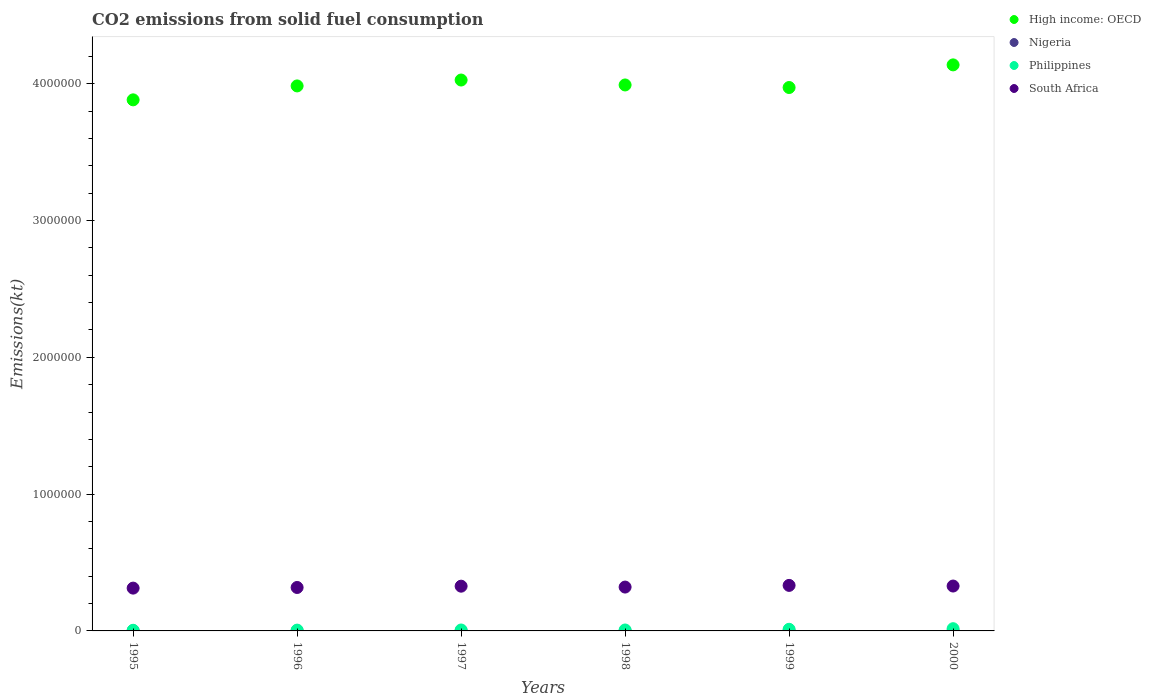How many different coloured dotlines are there?
Provide a short and direct response. 4. What is the amount of CO2 emitted in Philippines in 1995?
Make the answer very short. 4697.43. Across all years, what is the maximum amount of CO2 emitted in Philippines?
Your answer should be compact. 1.63e+04. Across all years, what is the minimum amount of CO2 emitted in Philippines?
Provide a short and direct response. 4697.43. What is the total amount of CO2 emitted in South Africa in the graph?
Your answer should be compact. 1.94e+06. What is the difference between the amount of CO2 emitted in Philippines in 1996 and that in 2000?
Offer a terse response. -1.04e+04. What is the difference between the amount of CO2 emitted in South Africa in 1998 and the amount of CO2 emitted in High income: OECD in 1996?
Provide a succinct answer. -3.66e+06. What is the average amount of CO2 emitted in Philippines per year?
Ensure brevity in your answer.  8743.96. In the year 1996, what is the difference between the amount of CO2 emitted in South Africa and amount of CO2 emitted in Nigeria?
Provide a short and direct response. 3.17e+05. In how many years, is the amount of CO2 emitted in Nigeria greater than 400000 kt?
Ensure brevity in your answer.  0. What is the ratio of the amount of CO2 emitted in High income: OECD in 1996 to that in 1999?
Provide a succinct answer. 1. Is the difference between the amount of CO2 emitted in South Africa in 1995 and 1999 greater than the difference between the amount of CO2 emitted in Nigeria in 1995 and 1999?
Give a very brief answer. No. What is the difference between the highest and the second highest amount of CO2 emitted in Philippines?
Make the answer very short. 4429.74. What is the difference between the highest and the lowest amount of CO2 emitted in Nigeria?
Give a very brief answer. 370.37. Is the sum of the amount of CO2 emitted in Nigeria in 1995 and 1997 greater than the maximum amount of CO2 emitted in Philippines across all years?
Your answer should be compact. No. Is it the case that in every year, the sum of the amount of CO2 emitted in High income: OECD and amount of CO2 emitted in South Africa  is greater than the amount of CO2 emitted in Nigeria?
Offer a very short reply. Yes. Is the amount of CO2 emitted in Nigeria strictly greater than the amount of CO2 emitted in High income: OECD over the years?
Keep it short and to the point. No. Is the amount of CO2 emitted in Nigeria strictly less than the amount of CO2 emitted in Philippines over the years?
Offer a terse response. Yes. How many dotlines are there?
Your response must be concise. 4. Does the graph contain any zero values?
Ensure brevity in your answer.  No. Does the graph contain grids?
Provide a succinct answer. No. How are the legend labels stacked?
Offer a very short reply. Vertical. What is the title of the graph?
Provide a short and direct response. CO2 emissions from solid fuel consumption. What is the label or title of the X-axis?
Ensure brevity in your answer.  Years. What is the label or title of the Y-axis?
Offer a very short reply. Emissions(kt). What is the Emissions(kt) of High income: OECD in 1995?
Give a very brief answer. 3.88e+06. What is the Emissions(kt) of Nigeria in 1995?
Offer a very short reply. 388.7. What is the Emissions(kt) of Philippines in 1995?
Your answer should be very brief. 4697.43. What is the Emissions(kt) of South Africa in 1995?
Keep it short and to the point. 3.13e+05. What is the Emissions(kt) in High income: OECD in 1996?
Your response must be concise. 3.98e+06. What is the Emissions(kt) in Nigeria in 1996?
Provide a succinct answer. 388.7. What is the Emissions(kt) of Philippines in 1996?
Give a very brief answer. 5907.54. What is the Emissions(kt) of South Africa in 1996?
Provide a succinct answer. 3.18e+05. What is the Emissions(kt) of High income: OECD in 1997?
Make the answer very short. 4.03e+06. What is the Emissions(kt) of Nigeria in 1997?
Offer a terse response. 44. What is the Emissions(kt) of Philippines in 1997?
Provide a short and direct response. 6794.95. What is the Emissions(kt) in South Africa in 1997?
Ensure brevity in your answer.  3.27e+05. What is the Emissions(kt) in High income: OECD in 1998?
Your response must be concise. 3.99e+06. What is the Emissions(kt) in Nigeria in 1998?
Your answer should be very brief. 47.67. What is the Emissions(kt) in Philippines in 1998?
Your response must be concise. 6864.62. What is the Emissions(kt) in South Africa in 1998?
Offer a terse response. 3.21e+05. What is the Emissions(kt) in High income: OECD in 1999?
Ensure brevity in your answer.  3.97e+06. What is the Emissions(kt) in Nigeria in 1999?
Offer a very short reply. 55.01. What is the Emissions(kt) of Philippines in 1999?
Your answer should be compact. 1.19e+04. What is the Emissions(kt) in South Africa in 1999?
Offer a very short reply. 3.33e+05. What is the Emissions(kt) of High income: OECD in 2000?
Your answer should be very brief. 4.14e+06. What is the Emissions(kt) of Nigeria in 2000?
Your response must be concise. 18.34. What is the Emissions(kt) in Philippines in 2000?
Ensure brevity in your answer.  1.63e+04. What is the Emissions(kt) of South Africa in 2000?
Provide a succinct answer. 3.28e+05. Across all years, what is the maximum Emissions(kt) of High income: OECD?
Your response must be concise. 4.14e+06. Across all years, what is the maximum Emissions(kt) in Nigeria?
Give a very brief answer. 388.7. Across all years, what is the maximum Emissions(kt) in Philippines?
Offer a very short reply. 1.63e+04. Across all years, what is the maximum Emissions(kt) of South Africa?
Your response must be concise. 3.33e+05. Across all years, what is the minimum Emissions(kt) in High income: OECD?
Keep it short and to the point. 3.88e+06. Across all years, what is the minimum Emissions(kt) in Nigeria?
Keep it short and to the point. 18.34. Across all years, what is the minimum Emissions(kt) of Philippines?
Provide a succinct answer. 4697.43. Across all years, what is the minimum Emissions(kt) of South Africa?
Your answer should be very brief. 3.13e+05. What is the total Emissions(kt) of High income: OECD in the graph?
Your response must be concise. 2.40e+07. What is the total Emissions(kt) in Nigeria in the graph?
Offer a terse response. 942.42. What is the total Emissions(kt) in Philippines in the graph?
Make the answer very short. 5.25e+04. What is the total Emissions(kt) in South Africa in the graph?
Make the answer very short. 1.94e+06. What is the difference between the Emissions(kt) of High income: OECD in 1995 and that in 1996?
Offer a terse response. -1.02e+05. What is the difference between the Emissions(kt) of Philippines in 1995 and that in 1996?
Ensure brevity in your answer.  -1210.11. What is the difference between the Emissions(kt) of South Africa in 1995 and that in 1996?
Provide a short and direct response. -4697.43. What is the difference between the Emissions(kt) in High income: OECD in 1995 and that in 1997?
Your response must be concise. -1.45e+05. What is the difference between the Emissions(kt) of Nigeria in 1995 and that in 1997?
Make the answer very short. 344.7. What is the difference between the Emissions(kt) of Philippines in 1995 and that in 1997?
Your answer should be compact. -2097.52. What is the difference between the Emissions(kt) in South Africa in 1995 and that in 1997?
Give a very brief answer. -1.42e+04. What is the difference between the Emissions(kt) in High income: OECD in 1995 and that in 1998?
Your answer should be very brief. -1.09e+05. What is the difference between the Emissions(kt) in Nigeria in 1995 and that in 1998?
Offer a terse response. 341.03. What is the difference between the Emissions(kt) in Philippines in 1995 and that in 1998?
Provide a succinct answer. -2167.2. What is the difference between the Emissions(kt) in South Africa in 1995 and that in 1998?
Ensure brevity in your answer.  -7693.37. What is the difference between the Emissions(kt) of High income: OECD in 1995 and that in 1999?
Keep it short and to the point. -9.01e+04. What is the difference between the Emissions(kt) in Nigeria in 1995 and that in 1999?
Your answer should be compact. 333.7. What is the difference between the Emissions(kt) of Philippines in 1995 and that in 1999?
Make the answer very short. -7187.32. What is the difference between the Emissions(kt) in South Africa in 1995 and that in 1999?
Make the answer very short. -1.99e+04. What is the difference between the Emissions(kt) in High income: OECD in 1995 and that in 2000?
Provide a short and direct response. -2.56e+05. What is the difference between the Emissions(kt) in Nigeria in 1995 and that in 2000?
Provide a succinct answer. 370.37. What is the difference between the Emissions(kt) in Philippines in 1995 and that in 2000?
Ensure brevity in your answer.  -1.16e+04. What is the difference between the Emissions(kt) of South Africa in 1995 and that in 2000?
Provide a succinct answer. -1.52e+04. What is the difference between the Emissions(kt) of High income: OECD in 1996 and that in 1997?
Provide a short and direct response. -4.31e+04. What is the difference between the Emissions(kt) of Nigeria in 1996 and that in 1997?
Your answer should be very brief. 344.7. What is the difference between the Emissions(kt) in Philippines in 1996 and that in 1997?
Keep it short and to the point. -887.41. What is the difference between the Emissions(kt) of South Africa in 1996 and that in 1997?
Keep it short and to the point. -9460.86. What is the difference between the Emissions(kt) of High income: OECD in 1996 and that in 1998?
Offer a terse response. -7058.98. What is the difference between the Emissions(kt) of Nigeria in 1996 and that in 1998?
Offer a very short reply. 341.03. What is the difference between the Emissions(kt) of Philippines in 1996 and that in 1998?
Your response must be concise. -957.09. What is the difference between the Emissions(kt) in South Africa in 1996 and that in 1998?
Your response must be concise. -2995.94. What is the difference between the Emissions(kt) of High income: OECD in 1996 and that in 1999?
Keep it short and to the point. 1.16e+04. What is the difference between the Emissions(kt) in Nigeria in 1996 and that in 1999?
Give a very brief answer. 333.7. What is the difference between the Emissions(kt) of Philippines in 1996 and that in 1999?
Ensure brevity in your answer.  -5977.21. What is the difference between the Emissions(kt) in South Africa in 1996 and that in 1999?
Provide a short and direct response. -1.52e+04. What is the difference between the Emissions(kt) of High income: OECD in 1996 and that in 2000?
Your answer should be compact. -1.54e+05. What is the difference between the Emissions(kt) of Nigeria in 1996 and that in 2000?
Offer a terse response. 370.37. What is the difference between the Emissions(kt) in Philippines in 1996 and that in 2000?
Keep it short and to the point. -1.04e+04. What is the difference between the Emissions(kt) of South Africa in 1996 and that in 2000?
Make the answer very short. -1.05e+04. What is the difference between the Emissions(kt) in High income: OECD in 1997 and that in 1998?
Offer a very short reply. 3.60e+04. What is the difference between the Emissions(kt) in Nigeria in 1997 and that in 1998?
Give a very brief answer. -3.67. What is the difference between the Emissions(kt) of Philippines in 1997 and that in 1998?
Give a very brief answer. -69.67. What is the difference between the Emissions(kt) in South Africa in 1997 and that in 1998?
Provide a short and direct response. 6464.92. What is the difference between the Emissions(kt) in High income: OECD in 1997 and that in 1999?
Your answer should be very brief. 5.47e+04. What is the difference between the Emissions(kt) in Nigeria in 1997 and that in 1999?
Offer a very short reply. -11. What is the difference between the Emissions(kt) in Philippines in 1997 and that in 1999?
Give a very brief answer. -5089.8. What is the difference between the Emissions(kt) of South Africa in 1997 and that in 1999?
Keep it short and to the point. -5771.86. What is the difference between the Emissions(kt) of High income: OECD in 1997 and that in 2000?
Ensure brevity in your answer.  -1.11e+05. What is the difference between the Emissions(kt) of Nigeria in 1997 and that in 2000?
Your answer should be compact. 25.67. What is the difference between the Emissions(kt) of Philippines in 1997 and that in 2000?
Provide a succinct answer. -9519.53. What is the difference between the Emissions(kt) in South Africa in 1997 and that in 2000?
Your response must be concise. -1059.76. What is the difference between the Emissions(kt) in High income: OECD in 1998 and that in 1999?
Offer a terse response. 1.87e+04. What is the difference between the Emissions(kt) of Nigeria in 1998 and that in 1999?
Keep it short and to the point. -7.33. What is the difference between the Emissions(kt) in Philippines in 1998 and that in 1999?
Keep it short and to the point. -5020.12. What is the difference between the Emissions(kt) of South Africa in 1998 and that in 1999?
Give a very brief answer. -1.22e+04. What is the difference between the Emissions(kt) in High income: OECD in 1998 and that in 2000?
Provide a short and direct response. -1.47e+05. What is the difference between the Emissions(kt) of Nigeria in 1998 and that in 2000?
Offer a terse response. 29.34. What is the difference between the Emissions(kt) of Philippines in 1998 and that in 2000?
Offer a terse response. -9449.86. What is the difference between the Emissions(kt) of South Africa in 1998 and that in 2000?
Provide a short and direct response. -7524.68. What is the difference between the Emissions(kt) in High income: OECD in 1999 and that in 2000?
Offer a terse response. -1.65e+05. What is the difference between the Emissions(kt) of Nigeria in 1999 and that in 2000?
Provide a short and direct response. 36.67. What is the difference between the Emissions(kt) of Philippines in 1999 and that in 2000?
Keep it short and to the point. -4429.74. What is the difference between the Emissions(kt) of South Africa in 1999 and that in 2000?
Your answer should be very brief. 4712.1. What is the difference between the Emissions(kt) in High income: OECD in 1995 and the Emissions(kt) in Nigeria in 1996?
Provide a succinct answer. 3.88e+06. What is the difference between the Emissions(kt) in High income: OECD in 1995 and the Emissions(kt) in Philippines in 1996?
Make the answer very short. 3.88e+06. What is the difference between the Emissions(kt) of High income: OECD in 1995 and the Emissions(kt) of South Africa in 1996?
Offer a very short reply. 3.56e+06. What is the difference between the Emissions(kt) in Nigeria in 1995 and the Emissions(kt) in Philippines in 1996?
Keep it short and to the point. -5518.84. What is the difference between the Emissions(kt) of Nigeria in 1995 and the Emissions(kt) of South Africa in 1996?
Ensure brevity in your answer.  -3.17e+05. What is the difference between the Emissions(kt) of Philippines in 1995 and the Emissions(kt) of South Africa in 1996?
Provide a succinct answer. -3.13e+05. What is the difference between the Emissions(kt) of High income: OECD in 1995 and the Emissions(kt) of Nigeria in 1997?
Provide a succinct answer. 3.88e+06. What is the difference between the Emissions(kt) in High income: OECD in 1995 and the Emissions(kt) in Philippines in 1997?
Your answer should be very brief. 3.88e+06. What is the difference between the Emissions(kt) of High income: OECD in 1995 and the Emissions(kt) of South Africa in 1997?
Your response must be concise. 3.56e+06. What is the difference between the Emissions(kt) in Nigeria in 1995 and the Emissions(kt) in Philippines in 1997?
Provide a succinct answer. -6406.25. What is the difference between the Emissions(kt) of Nigeria in 1995 and the Emissions(kt) of South Africa in 1997?
Provide a short and direct response. -3.27e+05. What is the difference between the Emissions(kt) in Philippines in 1995 and the Emissions(kt) in South Africa in 1997?
Your response must be concise. -3.22e+05. What is the difference between the Emissions(kt) of High income: OECD in 1995 and the Emissions(kt) of Nigeria in 1998?
Offer a terse response. 3.88e+06. What is the difference between the Emissions(kt) of High income: OECD in 1995 and the Emissions(kt) of Philippines in 1998?
Make the answer very short. 3.88e+06. What is the difference between the Emissions(kt) of High income: OECD in 1995 and the Emissions(kt) of South Africa in 1998?
Keep it short and to the point. 3.56e+06. What is the difference between the Emissions(kt) in Nigeria in 1995 and the Emissions(kt) in Philippines in 1998?
Provide a short and direct response. -6475.92. What is the difference between the Emissions(kt) of Nigeria in 1995 and the Emissions(kt) of South Africa in 1998?
Your answer should be very brief. -3.20e+05. What is the difference between the Emissions(kt) of Philippines in 1995 and the Emissions(kt) of South Africa in 1998?
Provide a succinct answer. -3.16e+05. What is the difference between the Emissions(kt) in High income: OECD in 1995 and the Emissions(kt) in Nigeria in 1999?
Make the answer very short. 3.88e+06. What is the difference between the Emissions(kt) of High income: OECD in 1995 and the Emissions(kt) of Philippines in 1999?
Your answer should be compact. 3.87e+06. What is the difference between the Emissions(kt) of High income: OECD in 1995 and the Emissions(kt) of South Africa in 1999?
Your answer should be very brief. 3.55e+06. What is the difference between the Emissions(kt) in Nigeria in 1995 and the Emissions(kt) in Philippines in 1999?
Offer a very short reply. -1.15e+04. What is the difference between the Emissions(kt) in Nigeria in 1995 and the Emissions(kt) in South Africa in 1999?
Your response must be concise. -3.32e+05. What is the difference between the Emissions(kt) in Philippines in 1995 and the Emissions(kt) in South Africa in 1999?
Your response must be concise. -3.28e+05. What is the difference between the Emissions(kt) of High income: OECD in 1995 and the Emissions(kt) of Nigeria in 2000?
Your answer should be compact. 3.88e+06. What is the difference between the Emissions(kt) in High income: OECD in 1995 and the Emissions(kt) in Philippines in 2000?
Make the answer very short. 3.87e+06. What is the difference between the Emissions(kt) of High income: OECD in 1995 and the Emissions(kt) of South Africa in 2000?
Keep it short and to the point. 3.55e+06. What is the difference between the Emissions(kt) in Nigeria in 1995 and the Emissions(kt) in Philippines in 2000?
Offer a terse response. -1.59e+04. What is the difference between the Emissions(kt) of Nigeria in 1995 and the Emissions(kt) of South Africa in 2000?
Keep it short and to the point. -3.28e+05. What is the difference between the Emissions(kt) of Philippines in 1995 and the Emissions(kt) of South Africa in 2000?
Provide a short and direct response. -3.23e+05. What is the difference between the Emissions(kt) of High income: OECD in 1996 and the Emissions(kt) of Nigeria in 1997?
Your response must be concise. 3.98e+06. What is the difference between the Emissions(kt) of High income: OECD in 1996 and the Emissions(kt) of Philippines in 1997?
Your answer should be very brief. 3.98e+06. What is the difference between the Emissions(kt) in High income: OECD in 1996 and the Emissions(kt) in South Africa in 1997?
Make the answer very short. 3.66e+06. What is the difference between the Emissions(kt) in Nigeria in 1996 and the Emissions(kt) in Philippines in 1997?
Keep it short and to the point. -6406.25. What is the difference between the Emissions(kt) in Nigeria in 1996 and the Emissions(kt) in South Africa in 1997?
Give a very brief answer. -3.27e+05. What is the difference between the Emissions(kt) of Philippines in 1996 and the Emissions(kt) of South Africa in 1997?
Offer a terse response. -3.21e+05. What is the difference between the Emissions(kt) of High income: OECD in 1996 and the Emissions(kt) of Nigeria in 1998?
Provide a short and direct response. 3.98e+06. What is the difference between the Emissions(kt) of High income: OECD in 1996 and the Emissions(kt) of Philippines in 1998?
Give a very brief answer. 3.98e+06. What is the difference between the Emissions(kt) of High income: OECD in 1996 and the Emissions(kt) of South Africa in 1998?
Provide a succinct answer. 3.66e+06. What is the difference between the Emissions(kt) of Nigeria in 1996 and the Emissions(kt) of Philippines in 1998?
Provide a short and direct response. -6475.92. What is the difference between the Emissions(kt) of Nigeria in 1996 and the Emissions(kt) of South Africa in 1998?
Provide a short and direct response. -3.20e+05. What is the difference between the Emissions(kt) of Philippines in 1996 and the Emissions(kt) of South Africa in 1998?
Your answer should be compact. -3.15e+05. What is the difference between the Emissions(kt) in High income: OECD in 1996 and the Emissions(kt) in Nigeria in 1999?
Make the answer very short. 3.98e+06. What is the difference between the Emissions(kt) in High income: OECD in 1996 and the Emissions(kt) in Philippines in 1999?
Make the answer very short. 3.97e+06. What is the difference between the Emissions(kt) in High income: OECD in 1996 and the Emissions(kt) in South Africa in 1999?
Your answer should be compact. 3.65e+06. What is the difference between the Emissions(kt) of Nigeria in 1996 and the Emissions(kt) of Philippines in 1999?
Provide a short and direct response. -1.15e+04. What is the difference between the Emissions(kt) in Nigeria in 1996 and the Emissions(kt) in South Africa in 1999?
Your answer should be very brief. -3.32e+05. What is the difference between the Emissions(kt) of Philippines in 1996 and the Emissions(kt) of South Africa in 1999?
Make the answer very short. -3.27e+05. What is the difference between the Emissions(kt) in High income: OECD in 1996 and the Emissions(kt) in Nigeria in 2000?
Give a very brief answer. 3.98e+06. What is the difference between the Emissions(kt) of High income: OECD in 1996 and the Emissions(kt) of Philippines in 2000?
Ensure brevity in your answer.  3.97e+06. What is the difference between the Emissions(kt) of High income: OECD in 1996 and the Emissions(kt) of South Africa in 2000?
Your answer should be very brief. 3.66e+06. What is the difference between the Emissions(kt) in Nigeria in 1996 and the Emissions(kt) in Philippines in 2000?
Make the answer very short. -1.59e+04. What is the difference between the Emissions(kt) of Nigeria in 1996 and the Emissions(kt) of South Africa in 2000?
Your answer should be compact. -3.28e+05. What is the difference between the Emissions(kt) of Philippines in 1996 and the Emissions(kt) of South Africa in 2000?
Offer a very short reply. -3.22e+05. What is the difference between the Emissions(kt) of High income: OECD in 1997 and the Emissions(kt) of Nigeria in 1998?
Provide a short and direct response. 4.03e+06. What is the difference between the Emissions(kt) of High income: OECD in 1997 and the Emissions(kt) of Philippines in 1998?
Give a very brief answer. 4.02e+06. What is the difference between the Emissions(kt) in High income: OECD in 1997 and the Emissions(kt) in South Africa in 1998?
Your answer should be very brief. 3.71e+06. What is the difference between the Emissions(kt) in Nigeria in 1997 and the Emissions(kt) in Philippines in 1998?
Offer a terse response. -6820.62. What is the difference between the Emissions(kt) of Nigeria in 1997 and the Emissions(kt) of South Africa in 1998?
Provide a short and direct response. -3.21e+05. What is the difference between the Emissions(kt) in Philippines in 1997 and the Emissions(kt) in South Africa in 1998?
Offer a terse response. -3.14e+05. What is the difference between the Emissions(kt) in High income: OECD in 1997 and the Emissions(kt) in Nigeria in 1999?
Offer a terse response. 4.03e+06. What is the difference between the Emissions(kt) in High income: OECD in 1997 and the Emissions(kt) in Philippines in 1999?
Ensure brevity in your answer.  4.02e+06. What is the difference between the Emissions(kt) in High income: OECD in 1997 and the Emissions(kt) in South Africa in 1999?
Give a very brief answer. 3.69e+06. What is the difference between the Emissions(kt) of Nigeria in 1997 and the Emissions(kt) of Philippines in 1999?
Provide a short and direct response. -1.18e+04. What is the difference between the Emissions(kt) in Nigeria in 1997 and the Emissions(kt) in South Africa in 1999?
Keep it short and to the point. -3.33e+05. What is the difference between the Emissions(kt) in Philippines in 1997 and the Emissions(kt) in South Africa in 1999?
Your answer should be compact. -3.26e+05. What is the difference between the Emissions(kt) of High income: OECD in 1997 and the Emissions(kt) of Nigeria in 2000?
Make the answer very short. 4.03e+06. What is the difference between the Emissions(kt) in High income: OECD in 1997 and the Emissions(kt) in Philippines in 2000?
Your answer should be very brief. 4.01e+06. What is the difference between the Emissions(kt) in High income: OECD in 1997 and the Emissions(kt) in South Africa in 2000?
Your answer should be very brief. 3.70e+06. What is the difference between the Emissions(kt) of Nigeria in 1997 and the Emissions(kt) of Philippines in 2000?
Your answer should be very brief. -1.63e+04. What is the difference between the Emissions(kt) of Nigeria in 1997 and the Emissions(kt) of South Africa in 2000?
Make the answer very short. -3.28e+05. What is the difference between the Emissions(kt) of Philippines in 1997 and the Emissions(kt) of South Africa in 2000?
Provide a succinct answer. -3.21e+05. What is the difference between the Emissions(kt) of High income: OECD in 1998 and the Emissions(kt) of Nigeria in 1999?
Your response must be concise. 3.99e+06. What is the difference between the Emissions(kt) in High income: OECD in 1998 and the Emissions(kt) in Philippines in 1999?
Offer a terse response. 3.98e+06. What is the difference between the Emissions(kt) of High income: OECD in 1998 and the Emissions(kt) of South Africa in 1999?
Your response must be concise. 3.66e+06. What is the difference between the Emissions(kt) in Nigeria in 1998 and the Emissions(kt) in Philippines in 1999?
Keep it short and to the point. -1.18e+04. What is the difference between the Emissions(kt) of Nigeria in 1998 and the Emissions(kt) of South Africa in 1999?
Offer a terse response. -3.33e+05. What is the difference between the Emissions(kt) in Philippines in 1998 and the Emissions(kt) in South Africa in 1999?
Your answer should be very brief. -3.26e+05. What is the difference between the Emissions(kt) of High income: OECD in 1998 and the Emissions(kt) of Nigeria in 2000?
Keep it short and to the point. 3.99e+06. What is the difference between the Emissions(kt) in High income: OECD in 1998 and the Emissions(kt) in Philippines in 2000?
Your answer should be very brief. 3.97e+06. What is the difference between the Emissions(kt) in High income: OECD in 1998 and the Emissions(kt) in South Africa in 2000?
Your answer should be compact. 3.66e+06. What is the difference between the Emissions(kt) of Nigeria in 1998 and the Emissions(kt) of Philippines in 2000?
Ensure brevity in your answer.  -1.63e+04. What is the difference between the Emissions(kt) in Nigeria in 1998 and the Emissions(kt) in South Africa in 2000?
Your answer should be very brief. -3.28e+05. What is the difference between the Emissions(kt) in Philippines in 1998 and the Emissions(kt) in South Africa in 2000?
Offer a terse response. -3.21e+05. What is the difference between the Emissions(kt) in High income: OECD in 1999 and the Emissions(kt) in Nigeria in 2000?
Ensure brevity in your answer.  3.97e+06. What is the difference between the Emissions(kt) in High income: OECD in 1999 and the Emissions(kt) in Philippines in 2000?
Your answer should be compact. 3.96e+06. What is the difference between the Emissions(kt) in High income: OECD in 1999 and the Emissions(kt) in South Africa in 2000?
Your response must be concise. 3.64e+06. What is the difference between the Emissions(kt) in Nigeria in 1999 and the Emissions(kt) in Philippines in 2000?
Offer a very short reply. -1.63e+04. What is the difference between the Emissions(kt) in Nigeria in 1999 and the Emissions(kt) in South Africa in 2000?
Ensure brevity in your answer.  -3.28e+05. What is the difference between the Emissions(kt) of Philippines in 1999 and the Emissions(kt) of South Africa in 2000?
Give a very brief answer. -3.16e+05. What is the average Emissions(kt) in High income: OECD per year?
Your response must be concise. 4.00e+06. What is the average Emissions(kt) in Nigeria per year?
Give a very brief answer. 157.07. What is the average Emissions(kt) in Philippines per year?
Your answer should be compact. 8743.96. What is the average Emissions(kt) of South Africa per year?
Ensure brevity in your answer.  3.23e+05. In the year 1995, what is the difference between the Emissions(kt) in High income: OECD and Emissions(kt) in Nigeria?
Ensure brevity in your answer.  3.88e+06. In the year 1995, what is the difference between the Emissions(kt) in High income: OECD and Emissions(kt) in Philippines?
Make the answer very short. 3.88e+06. In the year 1995, what is the difference between the Emissions(kt) of High income: OECD and Emissions(kt) of South Africa?
Provide a short and direct response. 3.57e+06. In the year 1995, what is the difference between the Emissions(kt) in Nigeria and Emissions(kt) in Philippines?
Your answer should be very brief. -4308.73. In the year 1995, what is the difference between the Emissions(kt) in Nigeria and Emissions(kt) in South Africa?
Offer a terse response. -3.12e+05. In the year 1995, what is the difference between the Emissions(kt) of Philippines and Emissions(kt) of South Africa?
Your answer should be compact. -3.08e+05. In the year 1996, what is the difference between the Emissions(kt) in High income: OECD and Emissions(kt) in Nigeria?
Your answer should be very brief. 3.98e+06. In the year 1996, what is the difference between the Emissions(kt) in High income: OECD and Emissions(kt) in Philippines?
Provide a short and direct response. 3.98e+06. In the year 1996, what is the difference between the Emissions(kt) of High income: OECD and Emissions(kt) of South Africa?
Offer a very short reply. 3.67e+06. In the year 1996, what is the difference between the Emissions(kt) of Nigeria and Emissions(kt) of Philippines?
Make the answer very short. -5518.84. In the year 1996, what is the difference between the Emissions(kt) of Nigeria and Emissions(kt) of South Africa?
Your response must be concise. -3.17e+05. In the year 1996, what is the difference between the Emissions(kt) of Philippines and Emissions(kt) of South Africa?
Your answer should be compact. -3.12e+05. In the year 1997, what is the difference between the Emissions(kt) of High income: OECD and Emissions(kt) of Nigeria?
Your response must be concise. 4.03e+06. In the year 1997, what is the difference between the Emissions(kt) of High income: OECD and Emissions(kt) of Philippines?
Your answer should be very brief. 4.02e+06. In the year 1997, what is the difference between the Emissions(kt) of High income: OECD and Emissions(kt) of South Africa?
Keep it short and to the point. 3.70e+06. In the year 1997, what is the difference between the Emissions(kt) of Nigeria and Emissions(kt) of Philippines?
Ensure brevity in your answer.  -6750.95. In the year 1997, what is the difference between the Emissions(kt) in Nigeria and Emissions(kt) in South Africa?
Give a very brief answer. -3.27e+05. In the year 1997, what is the difference between the Emissions(kt) in Philippines and Emissions(kt) in South Africa?
Provide a short and direct response. -3.20e+05. In the year 1998, what is the difference between the Emissions(kt) in High income: OECD and Emissions(kt) in Nigeria?
Make the answer very short. 3.99e+06. In the year 1998, what is the difference between the Emissions(kt) in High income: OECD and Emissions(kt) in Philippines?
Your answer should be very brief. 3.98e+06. In the year 1998, what is the difference between the Emissions(kt) in High income: OECD and Emissions(kt) in South Africa?
Offer a terse response. 3.67e+06. In the year 1998, what is the difference between the Emissions(kt) of Nigeria and Emissions(kt) of Philippines?
Make the answer very short. -6816.95. In the year 1998, what is the difference between the Emissions(kt) in Nigeria and Emissions(kt) in South Africa?
Keep it short and to the point. -3.21e+05. In the year 1998, what is the difference between the Emissions(kt) in Philippines and Emissions(kt) in South Africa?
Your answer should be very brief. -3.14e+05. In the year 1999, what is the difference between the Emissions(kt) in High income: OECD and Emissions(kt) in Nigeria?
Offer a terse response. 3.97e+06. In the year 1999, what is the difference between the Emissions(kt) in High income: OECD and Emissions(kt) in Philippines?
Ensure brevity in your answer.  3.96e+06. In the year 1999, what is the difference between the Emissions(kt) of High income: OECD and Emissions(kt) of South Africa?
Your answer should be very brief. 3.64e+06. In the year 1999, what is the difference between the Emissions(kt) in Nigeria and Emissions(kt) in Philippines?
Ensure brevity in your answer.  -1.18e+04. In the year 1999, what is the difference between the Emissions(kt) of Nigeria and Emissions(kt) of South Africa?
Give a very brief answer. -3.33e+05. In the year 1999, what is the difference between the Emissions(kt) in Philippines and Emissions(kt) in South Africa?
Make the answer very short. -3.21e+05. In the year 2000, what is the difference between the Emissions(kt) of High income: OECD and Emissions(kt) of Nigeria?
Your answer should be compact. 4.14e+06. In the year 2000, what is the difference between the Emissions(kt) of High income: OECD and Emissions(kt) of Philippines?
Your answer should be compact. 4.12e+06. In the year 2000, what is the difference between the Emissions(kt) in High income: OECD and Emissions(kt) in South Africa?
Your response must be concise. 3.81e+06. In the year 2000, what is the difference between the Emissions(kt) in Nigeria and Emissions(kt) in Philippines?
Keep it short and to the point. -1.63e+04. In the year 2000, what is the difference between the Emissions(kt) in Nigeria and Emissions(kt) in South Africa?
Your answer should be very brief. -3.28e+05. In the year 2000, what is the difference between the Emissions(kt) of Philippines and Emissions(kt) of South Africa?
Keep it short and to the point. -3.12e+05. What is the ratio of the Emissions(kt) of High income: OECD in 1995 to that in 1996?
Your response must be concise. 0.97. What is the ratio of the Emissions(kt) of Nigeria in 1995 to that in 1996?
Provide a succinct answer. 1. What is the ratio of the Emissions(kt) in Philippines in 1995 to that in 1996?
Ensure brevity in your answer.  0.8. What is the ratio of the Emissions(kt) of South Africa in 1995 to that in 1996?
Offer a very short reply. 0.99. What is the ratio of the Emissions(kt) of High income: OECD in 1995 to that in 1997?
Ensure brevity in your answer.  0.96. What is the ratio of the Emissions(kt) of Nigeria in 1995 to that in 1997?
Make the answer very short. 8.83. What is the ratio of the Emissions(kt) in Philippines in 1995 to that in 1997?
Offer a terse response. 0.69. What is the ratio of the Emissions(kt) in South Africa in 1995 to that in 1997?
Keep it short and to the point. 0.96. What is the ratio of the Emissions(kt) of High income: OECD in 1995 to that in 1998?
Give a very brief answer. 0.97. What is the ratio of the Emissions(kt) of Nigeria in 1995 to that in 1998?
Ensure brevity in your answer.  8.15. What is the ratio of the Emissions(kt) in Philippines in 1995 to that in 1998?
Give a very brief answer. 0.68. What is the ratio of the Emissions(kt) of High income: OECD in 1995 to that in 1999?
Give a very brief answer. 0.98. What is the ratio of the Emissions(kt) in Nigeria in 1995 to that in 1999?
Your response must be concise. 7.07. What is the ratio of the Emissions(kt) of Philippines in 1995 to that in 1999?
Offer a very short reply. 0.4. What is the ratio of the Emissions(kt) of South Africa in 1995 to that in 1999?
Your answer should be compact. 0.94. What is the ratio of the Emissions(kt) of High income: OECD in 1995 to that in 2000?
Offer a terse response. 0.94. What is the ratio of the Emissions(kt) of Nigeria in 1995 to that in 2000?
Your answer should be very brief. 21.2. What is the ratio of the Emissions(kt) of Philippines in 1995 to that in 2000?
Provide a short and direct response. 0.29. What is the ratio of the Emissions(kt) in South Africa in 1995 to that in 2000?
Your response must be concise. 0.95. What is the ratio of the Emissions(kt) in High income: OECD in 1996 to that in 1997?
Provide a short and direct response. 0.99. What is the ratio of the Emissions(kt) in Nigeria in 1996 to that in 1997?
Provide a short and direct response. 8.83. What is the ratio of the Emissions(kt) in Philippines in 1996 to that in 1997?
Give a very brief answer. 0.87. What is the ratio of the Emissions(kt) in South Africa in 1996 to that in 1997?
Your answer should be compact. 0.97. What is the ratio of the Emissions(kt) of High income: OECD in 1996 to that in 1998?
Give a very brief answer. 1. What is the ratio of the Emissions(kt) of Nigeria in 1996 to that in 1998?
Keep it short and to the point. 8.15. What is the ratio of the Emissions(kt) in Philippines in 1996 to that in 1998?
Offer a terse response. 0.86. What is the ratio of the Emissions(kt) of High income: OECD in 1996 to that in 1999?
Provide a short and direct response. 1. What is the ratio of the Emissions(kt) of Nigeria in 1996 to that in 1999?
Keep it short and to the point. 7.07. What is the ratio of the Emissions(kt) in Philippines in 1996 to that in 1999?
Offer a terse response. 0.5. What is the ratio of the Emissions(kt) in South Africa in 1996 to that in 1999?
Provide a short and direct response. 0.95. What is the ratio of the Emissions(kt) of High income: OECD in 1996 to that in 2000?
Your answer should be very brief. 0.96. What is the ratio of the Emissions(kt) in Nigeria in 1996 to that in 2000?
Offer a terse response. 21.2. What is the ratio of the Emissions(kt) of Philippines in 1996 to that in 2000?
Offer a terse response. 0.36. What is the ratio of the Emissions(kt) of South Africa in 1996 to that in 2000?
Make the answer very short. 0.97. What is the ratio of the Emissions(kt) in High income: OECD in 1997 to that in 1998?
Ensure brevity in your answer.  1.01. What is the ratio of the Emissions(kt) in South Africa in 1997 to that in 1998?
Give a very brief answer. 1.02. What is the ratio of the Emissions(kt) in High income: OECD in 1997 to that in 1999?
Provide a succinct answer. 1.01. What is the ratio of the Emissions(kt) in Philippines in 1997 to that in 1999?
Provide a succinct answer. 0.57. What is the ratio of the Emissions(kt) of South Africa in 1997 to that in 1999?
Give a very brief answer. 0.98. What is the ratio of the Emissions(kt) in High income: OECD in 1997 to that in 2000?
Offer a terse response. 0.97. What is the ratio of the Emissions(kt) of Nigeria in 1997 to that in 2000?
Provide a short and direct response. 2.4. What is the ratio of the Emissions(kt) of Philippines in 1997 to that in 2000?
Your response must be concise. 0.42. What is the ratio of the Emissions(kt) of South Africa in 1997 to that in 2000?
Your answer should be very brief. 1. What is the ratio of the Emissions(kt) in Nigeria in 1998 to that in 1999?
Ensure brevity in your answer.  0.87. What is the ratio of the Emissions(kt) of Philippines in 1998 to that in 1999?
Ensure brevity in your answer.  0.58. What is the ratio of the Emissions(kt) in South Africa in 1998 to that in 1999?
Offer a very short reply. 0.96. What is the ratio of the Emissions(kt) of High income: OECD in 1998 to that in 2000?
Offer a very short reply. 0.96. What is the ratio of the Emissions(kt) of Philippines in 1998 to that in 2000?
Your response must be concise. 0.42. What is the ratio of the Emissions(kt) of South Africa in 1998 to that in 2000?
Keep it short and to the point. 0.98. What is the ratio of the Emissions(kt) in High income: OECD in 1999 to that in 2000?
Make the answer very short. 0.96. What is the ratio of the Emissions(kt) in Nigeria in 1999 to that in 2000?
Give a very brief answer. 3. What is the ratio of the Emissions(kt) of Philippines in 1999 to that in 2000?
Offer a very short reply. 0.73. What is the ratio of the Emissions(kt) in South Africa in 1999 to that in 2000?
Your answer should be very brief. 1.01. What is the difference between the highest and the second highest Emissions(kt) in High income: OECD?
Ensure brevity in your answer.  1.11e+05. What is the difference between the highest and the second highest Emissions(kt) in Nigeria?
Make the answer very short. 0. What is the difference between the highest and the second highest Emissions(kt) in Philippines?
Ensure brevity in your answer.  4429.74. What is the difference between the highest and the second highest Emissions(kt) in South Africa?
Give a very brief answer. 4712.1. What is the difference between the highest and the lowest Emissions(kt) of High income: OECD?
Offer a very short reply. 2.56e+05. What is the difference between the highest and the lowest Emissions(kt) of Nigeria?
Offer a very short reply. 370.37. What is the difference between the highest and the lowest Emissions(kt) in Philippines?
Keep it short and to the point. 1.16e+04. What is the difference between the highest and the lowest Emissions(kt) in South Africa?
Your answer should be very brief. 1.99e+04. 